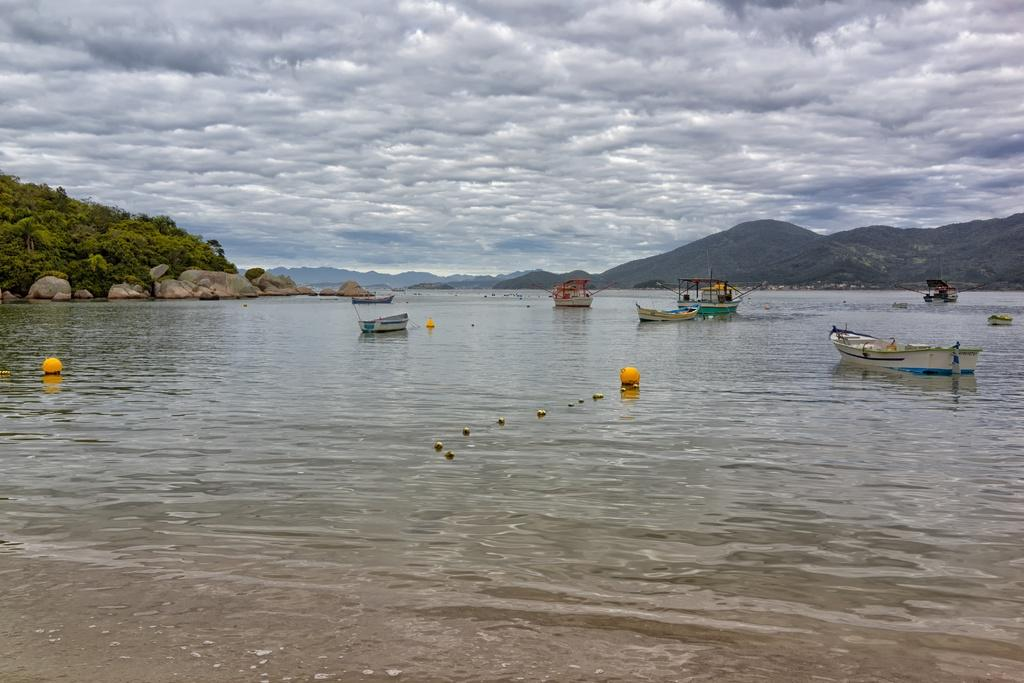What is on the water in the image? There are boats on the water in the image. What can be found in the left corner of the image? There are rocks and trees in the left corner of the image. What is visible in the right corner of the image? There are mountains in the right corner of the image. How would you describe the sky in the image? The sky is cloudy in the image. What type of fruit is hanging from the trees in the image? There is no fruit visible in the image; only rocks and trees are present in the left corner. Can you see any sparks coming from the boats in the image? There are no sparks present in the image; the boats are on the water, and the sky is cloudy. 